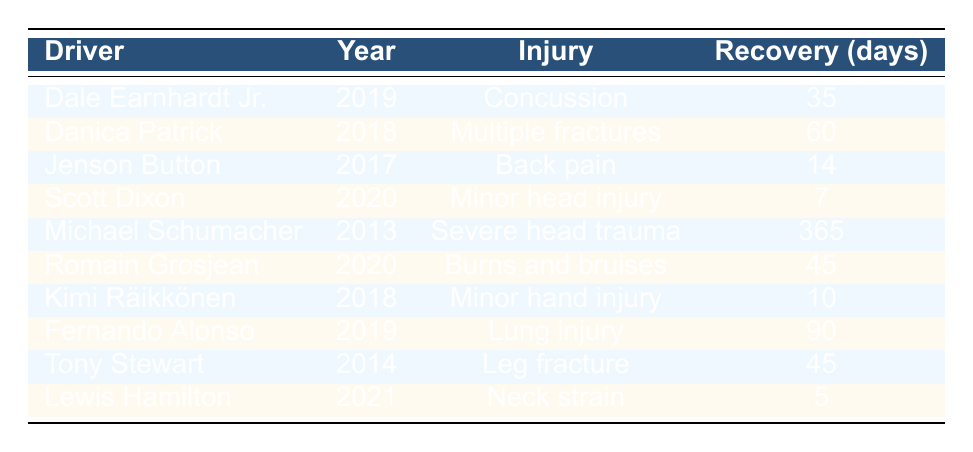What injury did Dale Earnhardt Jr. sustain in 2019? The table lists Dale Earnhardt Jr.'s injury as "Concussion" for the year 2019.
Answer: Concussion How long did it take Danica Patrick to recover from her injuries? The recovery time for Danica Patrick is stated as 60 days in the table.
Answer: 60 days Which driver had the longest recovery time? By examining the recovery times listed, Michael Schumacher's recovery time of 365 days is the longest of all.
Answer: 365 days Is there a driver who recovered in less than 10 days? Looking at the table, Scott Dixon had a recovery time of 7 days, which is less than 10 days.
Answer: Yes What is the average recovery time for the injuries listed? To find the average recovery time, we sum the recovery times: (35 + 60 + 14 + 7 + 365 + 45 + 10 + 90 + 45 + 5) = 676 days. There are 10 total entries, so the average is 676/10 = 67.6 days.
Answer: 67.6 days Which year had the most severe injury listed and what was the injury? The most severe injury is the "Severe head trauma" of Michael Schumacher in 2013 with a recovery time of 365 days.
Answer: 2013, Severe head trauma How many drivers sustained injuries in 2020? The table shows two entries for the year 2020: Scott Dixon with a minor head injury and Romain Grosjean with burns and bruises.
Answer: 2 drivers Which driver had a neck strain, and in what year did it occur? The table indicates that Lewis Hamilton had a neck strain in 2021.
Answer: Lewis Hamilton, 2021 Was there any driver that sustained injuries due to a racing accident? Analyzing the incidents listed, both Romain Grosjean and Dale Earnhardt Jr. had injuries that were due to racing accidents.
Answer: Yes What is the difference in recovery days between the longest and shortest recovery times? The longest recovery time is 365 days (Michael Schumacher), and the shortest is 5 days (Lewis Hamilton). The difference is 365 - 5 = 360 days.
Answer: 360 days 